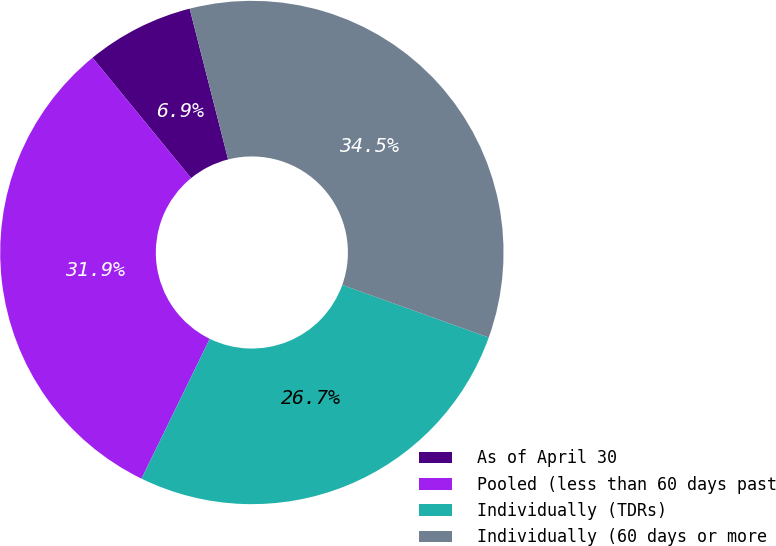Convert chart. <chart><loc_0><loc_0><loc_500><loc_500><pie_chart><fcel>As of April 30<fcel>Pooled (less than 60 days past<fcel>Individually (TDRs)<fcel>Individually (60 days or more<nl><fcel>6.94%<fcel>31.86%<fcel>26.74%<fcel>34.46%<nl></chart> 